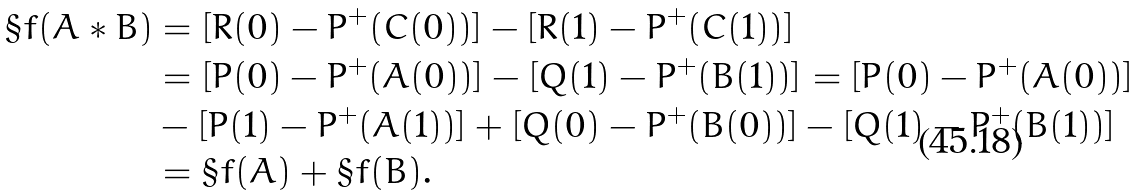<formula> <loc_0><loc_0><loc_500><loc_500>\S f ( A * B ) & = [ R ( 0 ) - P ^ { + } ( C ( 0 ) ) ] - [ R ( 1 ) - P ^ { + } ( C ( 1 ) ) ] \\ & = [ P ( 0 ) - P ^ { + } ( A ( 0 ) ) ] - [ Q ( 1 ) - P ^ { + } ( B ( 1 ) ) ] = [ P ( 0 ) - P ^ { + } ( A ( 0 ) ) ] \\ & - [ P ( 1 ) - P ^ { + } ( A ( 1 ) ) ] + [ Q ( 0 ) - P ^ { + } ( B ( 0 ) ) ] - [ Q ( 1 ) - P ^ { + } ( B ( 1 ) ) ] \\ & = \S f ( A ) + \S f ( B ) .</formula> 